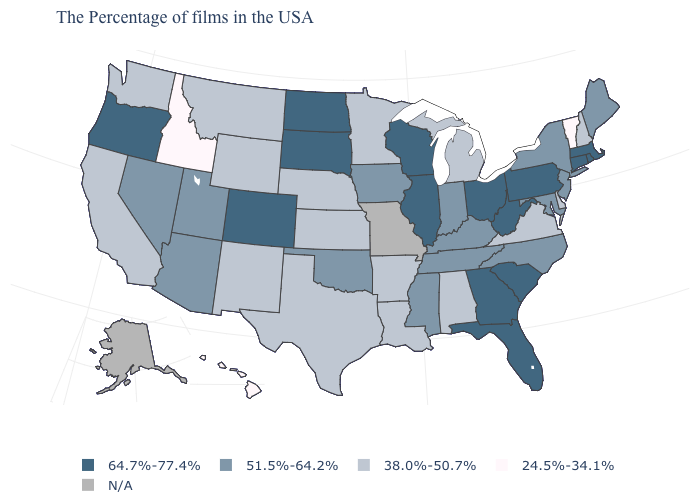What is the lowest value in the South?
Answer briefly. 38.0%-50.7%. What is the value of Oklahoma?
Answer briefly. 51.5%-64.2%. What is the value of Delaware?
Quick response, please. 38.0%-50.7%. Does New Mexico have the lowest value in the West?
Give a very brief answer. No. Which states have the highest value in the USA?
Quick response, please. Massachusetts, Rhode Island, Connecticut, Pennsylvania, South Carolina, West Virginia, Ohio, Florida, Georgia, Wisconsin, Illinois, South Dakota, North Dakota, Colorado, Oregon. Does Mississippi have the highest value in the South?
Write a very short answer. No. What is the lowest value in the South?
Quick response, please. 38.0%-50.7%. Name the states that have a value in the range N/A?
Keep it brief. Missouri, Alaska. Name the states that have a value in the range 64.7%-77.4%?
Write a very short answer. Massachusetts, Rhode Island, Connecticut, Pennsylvania, South Carolina, West Virginia, Ohio, Florida, Georgia, Wisconsin, Illinois, South Dakota, North Dakota, Colorado, Oregon. Name the states that have a value in the range 38.0%-50.7%?
Short answer required. New Hampshire, Delaware, Virginia, Michigan, Alabama, Louisiana, Arkansas, Minnesota, Kansas, Nebraska, Texas, Wyoming, New Mexico, Montana, California, Washington. What is the value of Washington?
Concise answer only. 38.0%-50.7%. Among the states that border Alabama , which have the lowest value?
Be succinct. Tennessee, Mississippi. What is the highest value in states that border Michigan?
Quick response, please. 64.7%-77.4%. What is the highest value in states that border Nebraska?
Keep it brief. 64.7%-77.4%. 